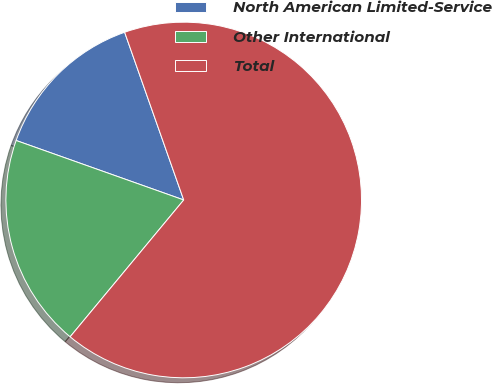Convert chart to OTSL. <chart><loc_0><loc_0><loc_500><loc_500><pie_chart><fcel>North American Limited-Service<fcel>Other International<fcel>Total<nl><fcel>14.18%<fcel>19.4%<fcel>66.41%<nl></chart> 